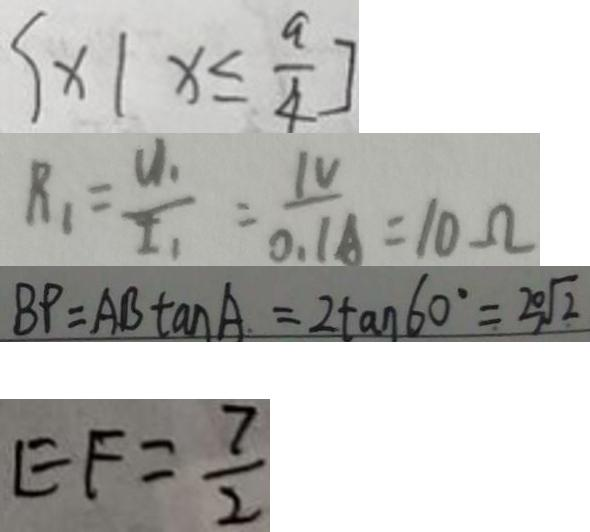<formula> <loc_0><loc_0><loc_500><loc_500>\{ x \vert x \leq \frac { a } { 4 } ] 
 R _ { 1 } = \frac { U _ { 1 } } { I _ { 1 } } = \frac { 1 V } { 0 . 1 A } = 1 0 \Omega 
 B P = A B \tan A = 2 \tan 6 0 ^ { \circ } = 2 0 \sqrt { 2 } 
 E F = \frac { 7 } { 2 }</formula> 